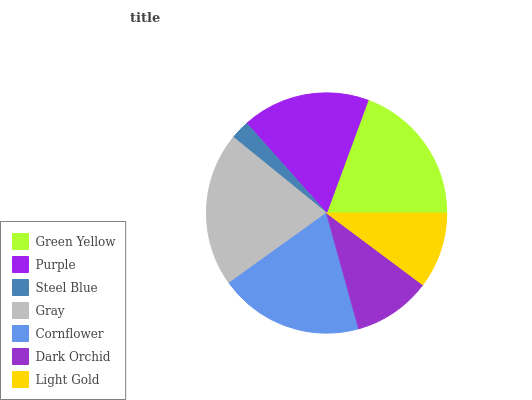Is Steel Blue the minimum?
Answer yes or no. Yes. Is Gray the maximum?
Answer yes or no. Yes. Is Purple the minimum?
Answer yes or no. No. Is Purple the maximum?
Answer yes or no. No. Is Green Yellow greater than Purple?
Answer yes or no. Yes. Is Purple less than Green Yellow?
Answer yes or no. Yes. Is Purple greater than Green Yellow?
Answer yes or no. No. Is Green Yellow less than Purple?
Answer yes or no. No. Is Purple the high median?
Answer yes or no. Yes. Is Purple the low median?
Answer yes or no. Yes. Is Light Gold the high median?
Answer yes or no. No. Is Cornflower the low median?
Answer yes or no. No. 